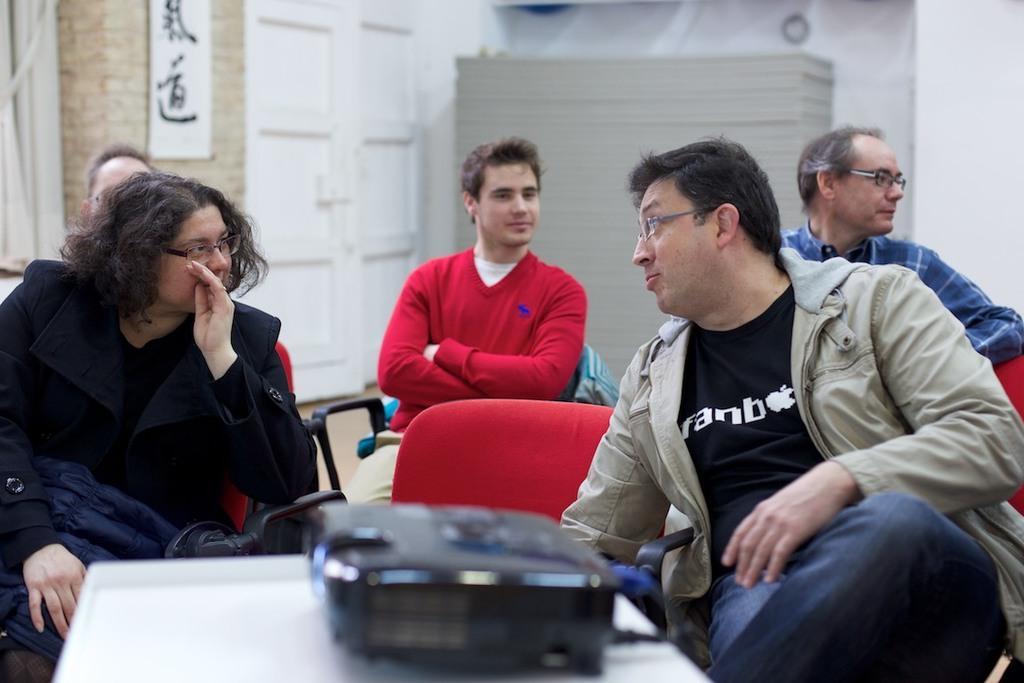In one or two sentences, can you explain what this image depicts? In this picture I can see 5 persons sitting on chairs in front and on the bottom of this picture I can see a table on which there is a black color thing. In the background I can see the wall. On the left top of this picture I can see a white board and I see something is written on it. 